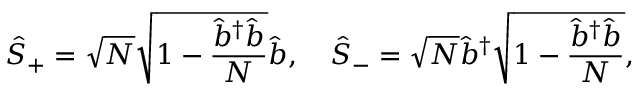<formula> <loc_0><loc_0><loc_500><loc_500>\hat { S } _ { + } = \sqrt { N } \sqrt { 1 - \frac { \hat { b } ^ { \dag } \hat { b } } { N } } \hat { b } , \quad \hat { S } _ { - } = \sqrt { N } \hat { b } ^ { \dag } \sqrt { 1 - \frac { \hat { b } ^ { \dag } \hat { b } } { N } } ,</formula> 